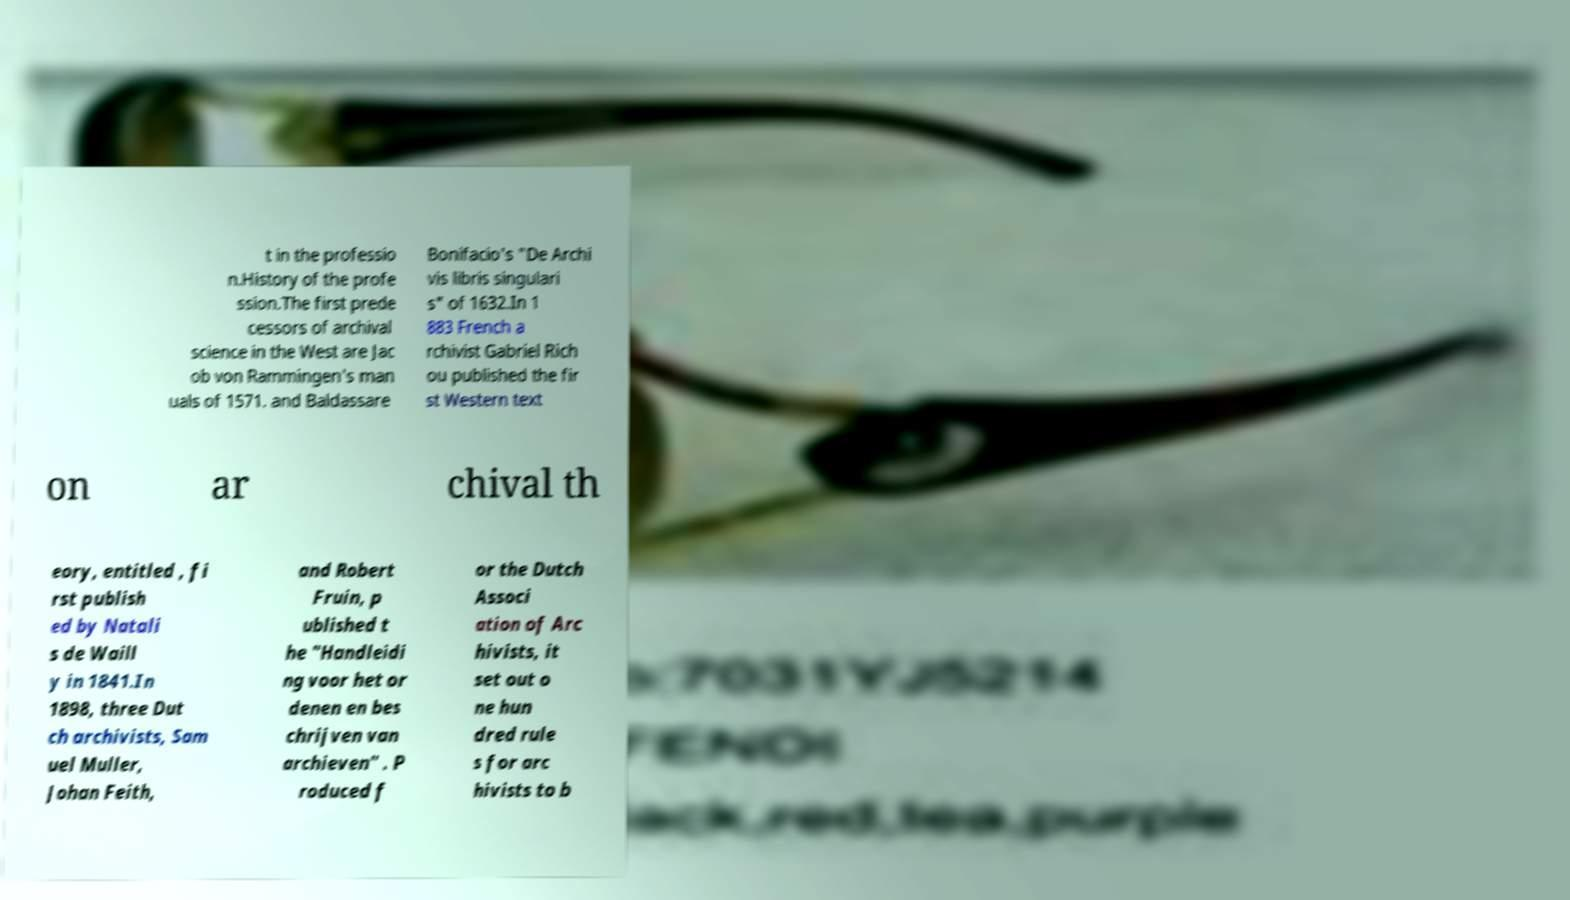Could you assist in decoding the text presented in this image and type it out clearly? t in the professio n.History of the profe ssion.The first prede cessors of archival science in the West are Jac ob von Rammingen's man uals of 1571. and Baldassare Bonifacio's "De Archi vis libris singulari s" of 1632.In 1 883 French a rchivist Gabriel Rich ou published the fir st Western text on ar chival th eory, entitled , fi rst publish ed by Natali s de Waill y in 1841.In 1898, three Dut ch archivists, Sam uel Muller, Johan Feith, and Robert Fruin, p ublished t he "Handleidi ng voor het or denen en bes chrijven van archieven" . P roduced f or the Dutch Associ ation of Arc hivists, it set out o ne hun dred rule s for arc hivists to b 